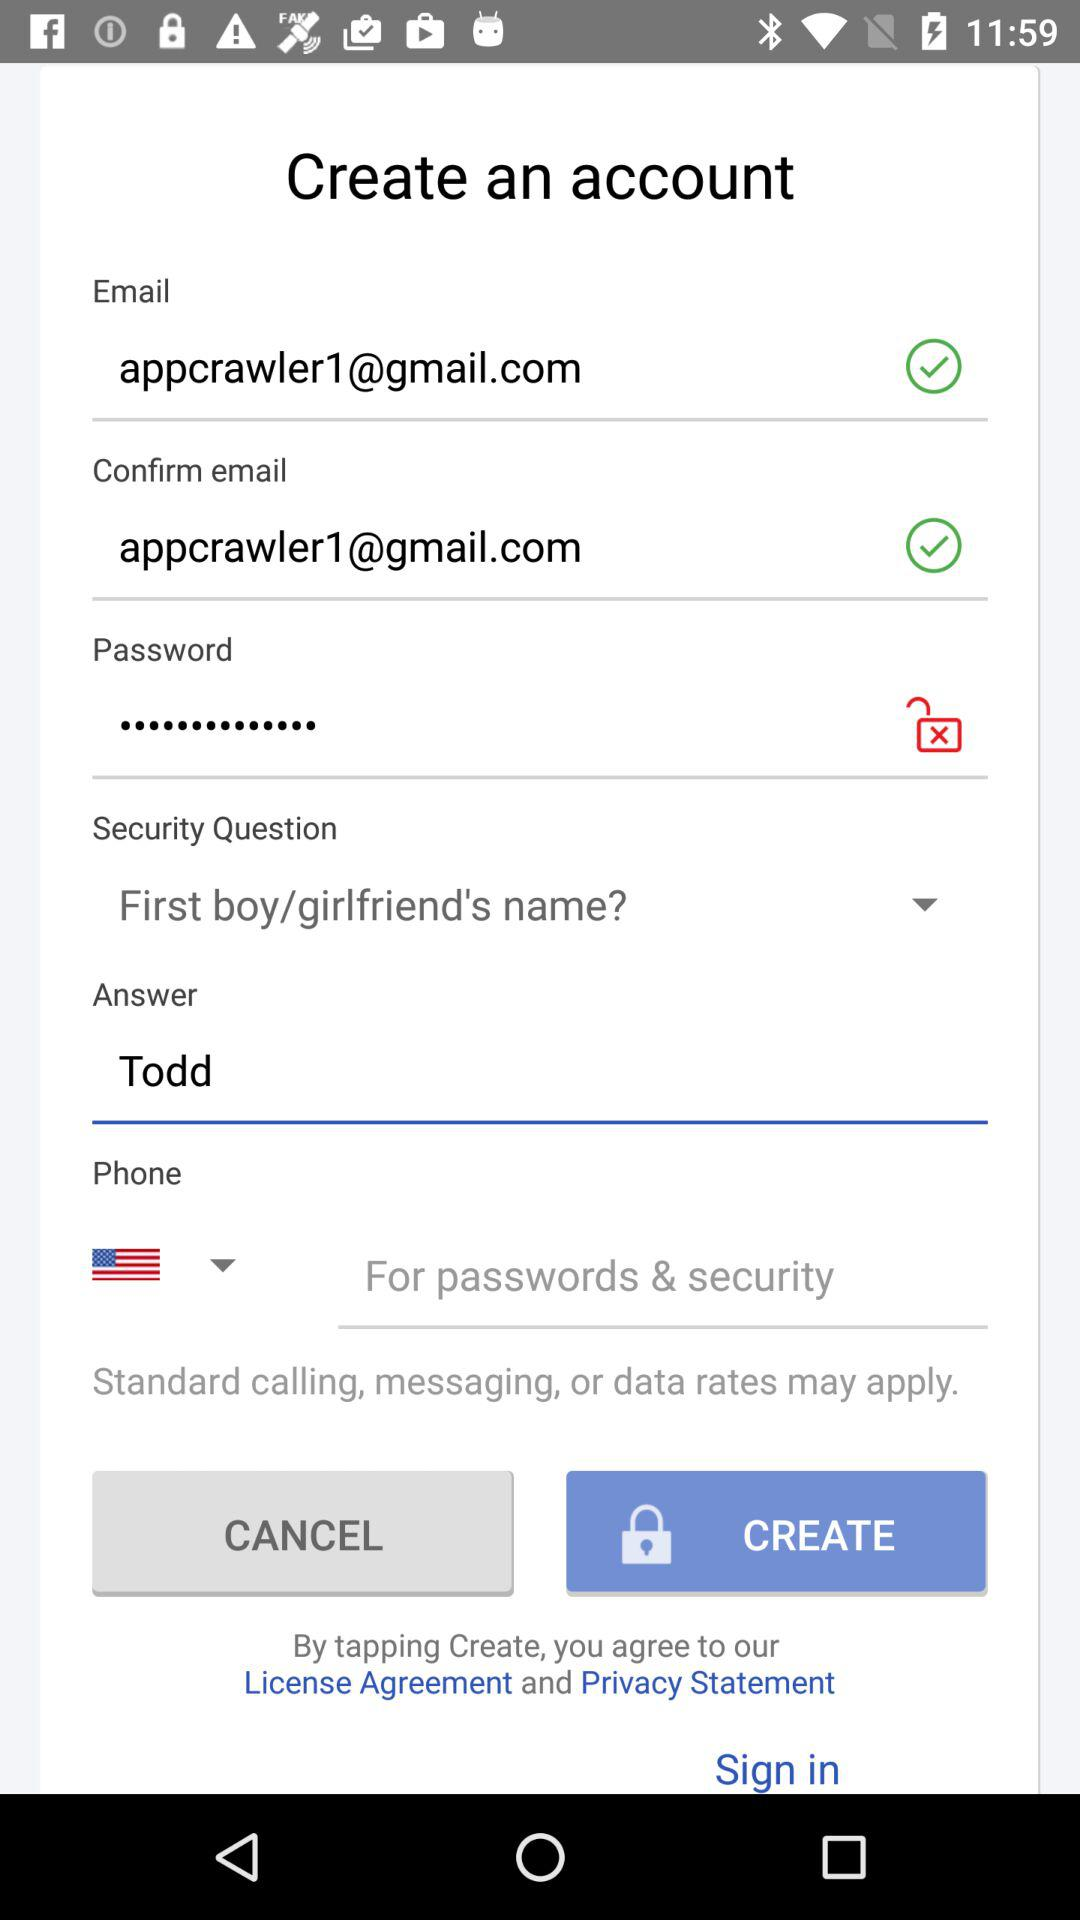What is the security answer? The answer is Todd. 